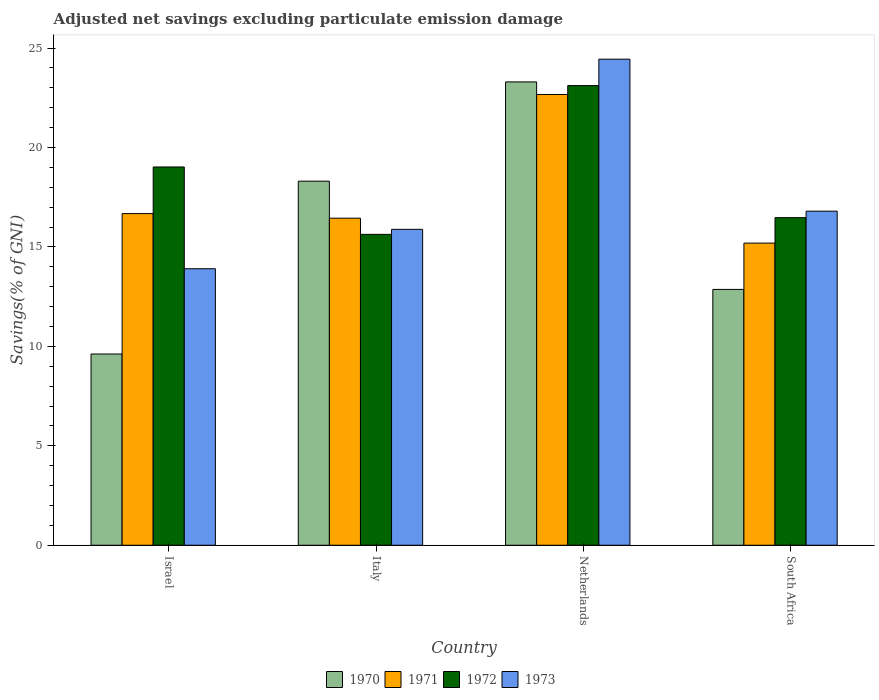How many groups of bars are there?
Your answer should be very brief. 4. Are the number of bars per tick equal to the number of legend labels?
Give a very brief answer. Yes. What is the label of the 3rd group of bars from the left?
Offer a terse response. Netherlands. In how many cases, is the number of bars for a given country not equal to the number of legend labels?
Your answer should be compact. 0. What is the adjusted net savings in 1972 in Israel?
Ensure brevity in your answer.  19.02. Across all countries, what is the maximum adjusted net savings in 1973?
Ensure brevity in your answer.  24.44. Across all countries, what is the minimum adjusted net savings in 1971?
Your answer should be very brief. 15.19. In which country was the adjusted net savings in 1973 maximum?
Provide a short and direct response. Netherlands. What is the total adjusted net savings in 1972 in the graph?
Your answer should be compact. 74.23. What is the difference between the adjusted net savings in 1972 in Israel and that in Netherlands?
Offer a very short reply. -4.09. What is the difference between the adjusted net savings in 1972 in Israel and the adjusted net savings in 1970 in Netherlands?
Offer a very short reply. -4.28. What is the average adjusted net savings in 1973 per country?
Give a very brief answer. 17.75. What is the difference between the adjusted net savings of/in 1972 and adjusted net savings of/in 1971 in Netherlands?
Your answer should be very brief. 0.45. What is the ratio of the adjusted net savings in 1970 in Netherlands to that in South Africa?
Offer a terse response. 1.81. What is the difference between the highest and the second highest adjusted net savings in 1971?
Your response must be concise. 0.23. What is the difference between the highest and the lowest adjusted net savings in 1972?
Give a very brief answer. 7.48. Is it the case that in every country, the sum of the adjusted net savings in 1970 and adjusted net savings in 1973 is greater than the sum of adjusted net savings in 1971 and adjusted net savings in 1972?
Give a very brief answer. No. What does the 1st bar from the left in Israel represents?
Keep it short and to the point. 1970. What does the 3rd bar from the right in Netherlands represents?
Your answer should be compact. 1971. How many bars are there?
Make the answer very short. 16. How many countries are there in the graph?
Your answer should be very brief. 4. Are the values on the major ticks of Y-axis written in scientific E-notation?
Keep it short and to the point. No. Does the graph contain grids?
Offer a terse response. No. Where does the legend appear in the graph?
Provide a short and direct response. Bottom center. How are the legend labels stacked?
Provide a short and direct response. Horizontal. What is the title of the graph?
Provide a succinct answer. Adjusted net savings excluding particulate emission damage. Does "2002" appear as one of the legend labels in the graph?
Make the answer very short. No. What is the label or title of the X-axis?
Provide a succinct answer. Country. What is the label or title of the Y-axis?
Provide a succinct answer. Savings(% of GNI). What is the Savings(% of GNI) of 1970 in Israel?
Your answer should be very brief. 9.61. What is the Savings(% of GNI) in 1971 in Israel?
Offer a terse response. 16.67. What is the Savings(% of GNI) of 1972 in Israel?
Offer a very short reply. 19.02. What is the Savings(% of GNI) in 1973 in Israel?
Provide a succinct answer. 13.9. What is the Savings(% of GNI) in 1970 in Italy?
Offer a terse response. 18.3. What is the Savings(% of GNI) of 1971 in Italy?
Your response must be concise. 16.44. What is the Savings(% of GNI) in 1972 in Italy?
Ensure brevity in your answer.  15.63. What is the Savings(% of GNI) in 1973 in Italy?
Provide a succinct answer. 15.88. What is the Savings(% of GNI) in 1970 in Netherlands?
Provide a short and direct response. 23.3. What is the Savings(% of GNI) in 1971 in Netherlands?
Give a very brief answer. 22.66. What is the Savings(% of GNI) in 1972 in Netherlands?
Your answer should be very brief. 23.11. What is the Savings(% of GNI) of 1973 in Netherlands?
Keep it short and to the point. 24.44. What is the Savings(% of GNI) of 1970 in South Africa?
Ensure brevity in your answer.  12.86. What is the Savings(% of GNI) of 1971 in South Africa?
Offer a terse response. 15.19. What is the Savings(% of GNI) in 1972 in South Africa?
Offer a terse response. 16.47. What is the Savings(% of GNI) of 1973 in South Africa?
Your answer should be compact. 16.8. Across all countries, what is the maximum Savings(% of GNI) of 1970?
Your answer should be very brief. 23.3. Across all countries, what is the maximum Savings(% of GNI) in 1971?
Offer a terse response. 22.66. Across all countries, what is the maximum Savings(% of GNI) of 1972?
Offer a very short reply. 23.11. Across all countries, what is the maximum Savings(% of GNI) of 1973?
Your response must be concise. 24.44. Across all countries, what is the minimum Savings(% of GNI) of 1970?
Your answer should be very brief. 9.61. Across all countries, what is the minimum Savings(% of GNI) in 1971?
Your answer should be very brief. 15.19. Across all countries, what is the minimum Savings(% of GNI) in 1972?
Provide a succinct answer. 15.63. Across all countries, what is the minimum Savings(% of GNI) of 1973?
Make the answer very short. 13.9. What is the total Savings(% of GNI) of 1970 in the graph?
Give a very brief answer. 64.08. What is the total Savings(% of GNI) of 1971 in the graph?
Give a very brief answer. 70.97. What is the total Savings(% of GNI) of 1972 in the graph?
Make the answer very short. 74.23. What is the total Savings(% of GNI) in 1973 in the graph?
Give a very brief answer. 71.02. What is the difference between the Savings(% of GNI) in 1970 in Israel and that in Italy?
Your answer should be compact. -8.69. What is the difference between the Savings(% of GNI) of 1971 in Israel and that in Italy?
Provide a succinct answer. 0.23. What is the difference between the Savings(% of GNI) of 1972 in Israel and that in Italy?
Your response must be concise. 3.39. What is the difference between the Savings(% of GNI) of 1973 in Israel and that in Italy?
Provide a short and direct response. -1.98. What is the difference between the Savings(% of GNI) of 1970 in Israel and that in Netherlands?
Provide a succinct answer. -13.68. What is the difference between the Savings(% of GNI) in 1971 in Israel and that in Netherlands?
Provide a succinct answer. -5.99. What is the difference between the Savings(% of GNI) in 1972 in Israel and that in Netherlands?
Offer a terse response. -4.09. What is the difference between the Savings(% of GNI) of 1973 in Israel and that in Netherlands?
Provide a succinct answer. -10.54. What is the difference between the Savings(% of GNI) in 1970 in Israel and that in South Africa?
Offer a terse response. -3.25. What is the difference between the Savings(% of GNI) of 1971 in Israel and that in South Africa?
Offer a very short reply. 1.48. What is the difference between the Savings(% of GNI) of 1972 in Israel and that in South Africa?
Your response must be concise. 2.55. What is the difference between the Savings(% of GNI) in 1973 in Israel and that in South Africa?
Provide a succinct answer. -2.89. What is the difference between the Savings(% of GNI) of 1970 in Italy and that in Netherlands?
Offer a very short reply. -4.99. What is the difference between the Savings(% of GNI) in 1971 in Italy and that in Netherlands?
Offer a very short reply. -6.22. What is the difference between the Savings(% of GNI) in 1972 in Italy and that in Netherlands?
Ensure brevity in your answer.  -7.48. What is the difference between the Savings(% of GNI) of 1973 in Italy and that in Netherlands?
Offer a very short reply. -8.56. What is the difference between the Savings(% of GNI) of 1970 in Italy and that in South Africa?
Offer a terse response. 5.44. What is the difference between the Savings(% of GNI) in 1971 in Italy and that in South Africa?
Make the answer very short. 1.25. What is the difference between the Savings(% of GNI) of 1972 in Italy and that in South Africa?
Give a very brief answer. -0.84. What is the difference between the Savings(% of GNI) in 1973 in Italy and that in South Africa?
Provide a succinct answer. -0.91. What is the difference between the Savings(% of GNI) of 1970 in Netherlands and that in South Africa?
Provide a short and direct response. 10.43. What is the difference between the Savings(% of GNI) of 1971 in Netherlands and that in South Africa?
Provide a short and direct response. 7.47. What is the difference between the Savings(% of GNI) in 1972 in Netherlands and that in South Africa?
Your answer should be very brief. 6.64. What is the difference between the Savings(% of GNI) of 1973 in Netherlands and that in South Africa?
Keep it short and to the point. 7.64. What is the difference between the Savings(% of GNI) of 1970 in Israel and the Savings(% of GNI) of 1971 in Italy?
Your answer should be very brief. -6.83. What is the difference between the Savings(% of GNI) of 1970 in Israel and the Savings(% of GNI) of 1972 in Italy?
Keep it short and to the point. -6.02. What is the difference between the Savings(% of GNI) in 1970 in Israel and the Savings(% of GNI) in 1973 in Italy?
Provide a short and direct response. -6.27. What is the difference between the Savings(% of GNI) in 1971 in Israel and the Savings(% of GNI) in 1972 in Italy?
Offer a very short reply. 1.04. What is the difference between the Savings(% of GNI) of 1971 in Israel and the Savings(% of GNI) of 1973 in Italy?
Make the answer very short. 0.79. What is the difference between the Savings(% of GNI) in 1972 in Israel and the Savings(% of GNI) in 1973 in Italy?
Keep it short and to the point. 3.14. What is the difference between the Savings(% of GNI) in 1970 in Israel and the Savings(% of GNI) in 1971 in Netherlands?
Your response must be concise. -13.05. What is the difference between the Savings(% of GNI) of 1970 in Israel and the Savings(% of GNI) of 1972 in Netherlands?
Provide a succinct answer. -13.49. What is the difference between the Savings(% of GNI) in 1970 in Israel and the Savings(% of GNI) in 1973 in Netherlands?
Your answer should be very brief. -14.82. What is the difference between the Savings(% of GNI) in 1971 in Israel and the Savings(% of GNI) in 1972 in Netherlands?
Your answer should be compact. -6.44. What is the difference between the Savings(% of GNI) of 1971 in Israel and the Savings(% of GNI) of 1973 in Netherlands?
Provide a succinct answer. -7.76. What is the difference between the Savings(% of GNI) in 1972 in Israel and the Savings(% of GNI) in 1973 in Netherlands?
Offer a terse response. -5.42. What is the difference between the Savings(% of GNI) of 1970 in Israel and the Savings(% of GNI) of 1971 in South Africa?
Offer a very short reply. -5.58. What is the difference between the Savings(% of GNI) in 1970 in Israel and the Savings(% of GNI) in 1972 in South Africa?
Provide a short and direct response. -6.86. What is the difference between the Savings(% of GNI) of 1970 in Israel and the Savings(% of GNI) of 1973 in South Africa?
Your answer should be compact. -7.18. What is the difference between the Savings(% of GNI) of 1971 in Israel and the Savings(% of GNI) of 1972 in South Africa?
Give a very brief answer. 0.2. What is the difference between the Savings(% of GNI) in 1971 in Israel and the Savings(% of GNI) in 1973 in South Africa?
Provide a succinct answer. -0.12. What is the difference between the Savings(% of GNI) of 1972 in Israel and the Savings(% of GNI) of 1973 in South Africa?
Give a very brief answer. 2.22. What is the difference between the Savings(% of GNI) of 1970 in Italy and the Savings(% of GNI) of 1971 in Netherlands?
Offer a terse response. -4.36. What is the difference between the Savings(% of GNI) of 1970 in Italy and the Savings(% of GNI) of 1972 in Netherlands?
Ensure brevity in your answer.  -4.81. What is the difference between the Savings(% of GNI) of 1970 in Italy and the Savings(% of GNI) of 1973 in Netherlands?
Give a very brief answer. -6.13. What is the difference between the Savings(% of GNI) in 1971 in Italy and the Savings(% of GNI) in 1972 in Netherlands?
Your response must be concise. -6.67. What is the difference between the Savings(% of GNI) in 1971 in Italy and the Savings(% of GNI) in 1973 in Netherlands?
Your response must be concise. -7.99. What is the difference between the Savings(% of GNI) in 1972 in Italy and the Savings(% of GNI) in 1973 in Netherlands?
Keep it short and to the point. -8.81. What is the difference between the Savings(% of GNI) of 1970 in Italy and the Savings(% of GNI) of 1971 in South Africa?
Give a very brief answer. 3.11. What is the difference between the Savings(% of GNI) of 1970 in Italy and the Savings(% of GNI) of 1972 in South Africa?
Offer a very short reply. 1.83. What is the difference between the Savings(% of GNI) of 1970 in Italy and the Savings(% of GNI) of 1973 in South Africa?
Provide a succinct answer. 1.51. What is the difference between the Savings(% of GNI) in 1971 in Italy and the Savings(% of GNI) in 1972 in South Africa?
Your answer should be compact. -0.03. What is the difference between the Savings(% of GNI) of 1971 in Italy and the Savings(% of GNI) of 1973 in South Africa?
Keep it short and to the point. -0.35. What is the difference between the Savings(% of GNI) of 1972 in Italy and the Savings(% of GNI) of 1973 in South Africa?
Keep it short and to the point. -1.17. What is the difference between the Savings(% of GNI) of 1970 in Netherlands and the Savings(% of GNI) of 1971 in South Africa?
Provide a short and direct response. 8.11. What is the difference between the Savings(% of GNI) in 1970 in Netherlands and the Savings(% of GNI) in 1972 in South Africa?
Your response must be concise. 6.83. What is the difference between the Savings(% of GNI) in 1970 in Netherlands and the Savings(% of GNI) in 1973 in South Africa?
Give a very brief answer. 6.5. What is the difference between the Savings(% of GNI) in 1971 in Netherlands and the Savings(% of GNI) in 1972 in South Africa?
Your answer should be very brief. 6.19. What is the difference between the Savings(% of GNI) in 1971 in Netherlands and the Savings(% of GNI) in 1973 in South Africa?
Your response must be concise. 5.87. What is the difference between the Savings(% of GNI) of 1972 in Netherlands and the Savings(% of GNI) of 1973 in South Africa?
Offer a very short reply. 6.31. What is the average Savings(% of GNI) of 1970 per country?
Make the answer very short. 16.02. What is the average Savings(% of GNI) in 1971 per country?
Offer a terse response. 17.74. What is the average Savings(% of GNI) in 1972 per country?
Keep it short and to the point. 18.56. What is the average Savings(% of GNI) in 1973 per country?
Make the answer very short. 17.75. What is the difference between the Savings(% of GNI) in 1970 and Savings(% of GNI) in 1971 in Israel?
Provide a succinct answer. -7.06. What is the difference between the Savings(% of GNI) in 1970 and Savings(% of GNI) in 1972 in Israel?
Ensure brevity in your answer.  -9.4. What is the difference between the Savings(% of GNI) in 1970 and Savings(% of GNI) in 1973 in Israel?
Offer a very short reply. -4.29. What is the difference between the Savings(% of GNI) of 1971 and Savings(% of GNI) of 1972 in Israel?
Make the answer very short. -2.34. What is the difference between the Savings(% of GNI) of 1971 and Savings(% of GNI) of 1973 in Israel?
Provide a short and direct response. 2.77. What is the difference between the Savings(% of GNI) of 1972 and Savings(% of GNI) of 1973 in Israel?
Offer a very short reply. 5.12. What is the difference between the Savings(% of GNI) in 1970 and Savings(% of GNI) in 1971 in Italy?
Give a very brief answer. 1.86. What is the difference between the Savings(% of GNI) in 1970 and Savings(% of GNI) in 1972 in Italy?
Your response must be concise. 2.67. What is the difference between the Savings(% of GNI) of 1970 and Savings(% of GNI) of 1973 in Italy?
Give a very brief answer. 2.42. What is the difference between the Savings(% of GNI) in 1971 and Savings(% of GNI) in 1972 in Italy?
Your response must be concise. 0.81. What is the difference between the Savings(% of GNI) in 1971 and Savings(% of GNI) in 1973 in Italy?
Give a very brief answer. 0.56. What is the difference between the Savings(% of GNI) in 1972 and Savings(% of GNI) in 1973 in Italy?
Ensure brevity in your answer.  -0.25. What is the difference between the Savings(% of GNI) of 1970 and Savings(% of GNI) of 1971 in Netherlands?
Ensure brevity in your answer.  0.63. What is the difference between the Savings(% of GNI) in 1970 and Savings(% of GNI) in 1972 in Netherlands?
Provide a succinct answer. 0.19. What is the difference between the Savings(% of GNI) in 1970 and Savings(% of GNI) in 1973 in Netherlands?
Your answer should be compact. -1.14. What is the difference between the Savings(% of GNI) in 1971 and Savings(% of GNI) in 1972 in Netherlands?
Your response must be concise. -0.45. What is the difference between the Savings(% of GNI) in 1971 and Savings(% of GNI) in 1973 in Netherlands?
Provide a succinct answer. -1.77. What is the difference between the Savings(% of GNI) of 1972 and Savings(% of GNI) of 1973 in Netherlands?
Provide a short and direct response. -1.33. What is the difference between the Savings(% of GNI) in 1970 and Savings(% of GNI) in 1971 in South Africa?
Offer a very short reply. -2.33. What is the difference between the Savings(% of GNI) of 1970 and Savings(% of GNI) of 1972 in South Africa?
Provide a succinct answer. -3.61. What is the difference between the Savings(% of GNI) in 1970 and Savings(% of GNI) in 1973 in South Africa?
Your answer should be compact. -3.93. What is the difference between the Savings(% of GNI) of 1971 and Savings(% of GNI) of 1972 in South Africa?
Keep it short and to the point. -1.28. What is the difference between the Savings(% of GNI) of 1971 and Savings(% of GNI) of 1973 in South Africa?
Keep it short and to the point. -1.61. What is the difference between the Savings(% of GNI) of 1972 and Savings(% of GNI) of 1973 in South Africa?
Offer a terse response. -0.33. What is the ratio of the Savings(% of GNI) in 1970 in Israel to that in Italy?
Give a very brief answer. 0.53. What is the ratio of the Savings(% of GNI) in 1972 in Israel to that in Italy?
Offer a terse response. 1.22. What is the ratio of the Savings(% of GNI) in 1973 in Israel to that in Italy?
Provide a succinct answer. 0.88. What is the ratio of the Savings(% of GNI) in 1970 in Israel to that in Netherlands?
Provide a succinct answer. 0.41. What is the ratio of the Savings(% of GNI) in 1971 in Israel to that in Netherlands?
Provide a short and direct response. 0.74. What is the ratio of the Savings(% of GNI) in 1972 in Israel to that in Netherlands?
Offer a very short reply. 0.82. What is the ratio of the Savings(% of GNI) of 1973 in Israel to that in Netherlands?
Your response must be concise. 0.57. What is the ratio of the Savings(% of GNI) in 1970 in Israel to that in South Africa?
Provide a succinct answer. 0.75. What is the ratio of the Savings(% of GNI) of 1971 in Israel to that in South Africa?
Offer a very short reply. 1.1. What is the ratio of the Savings(% of GNI) of 1972 in Israel to that in South Africa?
Your answer should be compact. 1.15. What is the ratio of the Savings(% of GNI) of 1973 in Israel to that in South Africa?
Make the answer very short. 0.83. What is the ratio of the Savings(% of GNI) of 1970 in Italy to that in Netherlands?
Provide a succinct answer. 0.79. What is the ratio of the Savings(% of GNI) of 1971 in Italy to that in Netherlands?
Your response must be concise. 0.73. What is the ratio of the Savings(% of GNI) in 1972 in Italy to that in Netherlands?
Your answer should be very brief. 0.68. What is the ratio of the Savings(% of GNI) in 1973 in Italy to that in Netherlands?
Your response must be concise. 0.65. What is the ratio of the Savings(% of GNI) in 1970 in Italy to that in South Africa?
Ensure brevity in your answer.  1.42. What is the ratio of the Savings(% of GNI) in 1971 in Italy to that in South Africa?
Offer a terse response. 1.08. What is the ratio of the Savings(% of GNI) in 1972 in Italy to that in South Africa?
Make the answer very short. 0.95. What is the ratio of the Savings(% of GNI) in 1973 in Italy to that in South Africa?
Provide a succinct answer. 0.95. What is the ratio of the Savings(% of GNI) of 1970 in Netherlands to that in South Africa?
Give a very brief answer. 1.81. What is the ratio of the Savings(% of GNI) of 1971 in Netherlands to that in South Africa?
Provide a short and direct response. 1.49. What is the ratio of the Savings(% of GNI) of 1972 in Netherlands to that in South Africa?
Keep it short and to the point. 1.4. What is the ratio of the Savings(% of GNI) in 1973 in Netherlands to that in South Africa?
Your answer should be very brief. 1.46. What is the difference between the highest and the second highest Savings(% of GNI) in 1970?
Ensure brevity in your answer.  4.99. What is the difference between the highest and the second highest Savings(% of GNI) of 1971?
Ensure brevity in your answer.  5.99. What is the difference between the highest and the second highest Savings(% of GNI) in 1972?
Your answer should be compact. 4.09. What is the difference between the highest and the second highest Savings(% of GNI) of 1973?
Keep it short and to the point. 7.64. What is the difference between the highest and the lowest Savings(% of GNI) of 1970?
Offer a terse response. 13.68. What is the difference between the highest and the lowest Savings(% of GNI) in 1971?
Offer a very short reply. 7.47. What is the difference between the highest and the lowest Savings(% of GNI) of 1972?
Ensure brevity in your answer.  7.48. What is the difference between the highest and the lowest Savings(% of GNI) of 1973?
Make the answer very short. 10.54. 